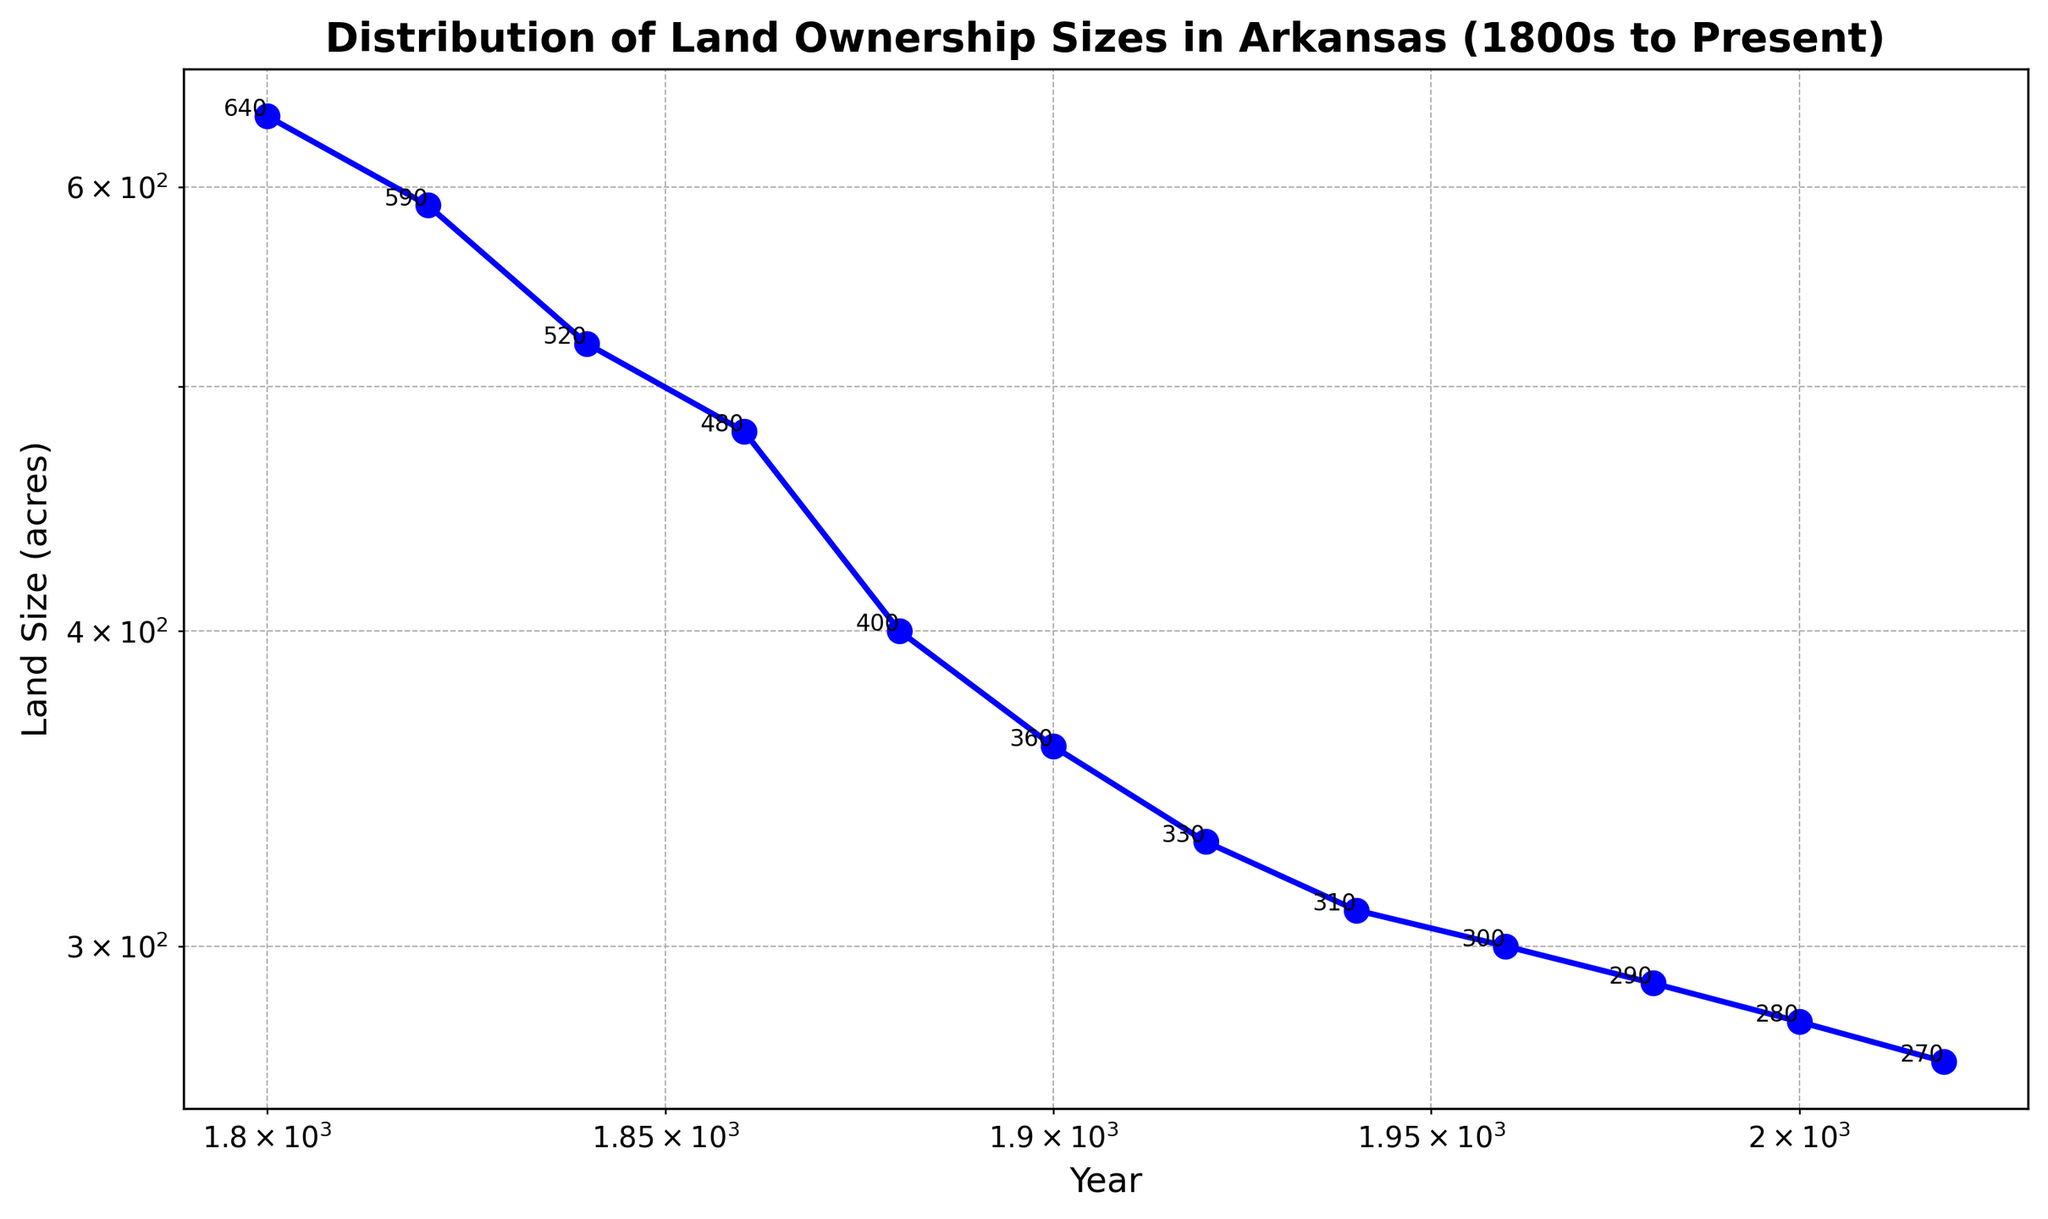Which decade has the most significant decrease in land ownership size? To determine the most significant decrease between decades, we look at the differences between the land sizes in consecutive data points. The calculation would be as follows: 640-590 (50), 590-520 (70), 520-480 (40), 480-400 (80), 400-360 (40), 360-330 (30), 330-310 (20), 310-300 (10), 300-290 (10), 290-280 (10), 280-270 (10). The largest decrease occurs between 1860 and 1880 with 80 acres.
Answer: 1860-1880 What is the average land ownership size over the entire timeline? To find the average, sum all the land ownership sizes and then divide by the number of data points. The sum is 640 + 590 + 520 + 480 + 400 + 360 + 330 + 310 + 300 + 290 + 280 + 270 = 4770 acres. Dividing by 12 data points gives 4770/12.
Answer: 397.5 acres Which period between consecutive years had the least change in land ownership size? Look for the smallest difference in land sizes between consecutive years. The differences calculated are: 640-590 (50), 590-520 (70), 520-480 (40), 480-400 (80), 400-360 (40), 360-330 (30), 330-310 (20), 310-300 (10), 300-290 (10), 290-280 (10), 280-270 (10). The periods 310-300, 300-290, 290-280, and 280-270 all had a decrease of 10 acres, representing the least change.
Answer: 2010-2020 In what year was the land size closest to 500 acres? By examining the land sizes, we notice that in 1840 the size was 520 acres and in 1860 it was 480 acres. The closest is 480 acres in 1860.
Answer: 1860 Which decade shows a decrease in land size by more than 50 acres? Calculate the decrease for each decade. From the differences we earlier calculated: 640-590 (50), 590-520 (70), 520-480 (40), 480-400 (80), 400-360 (40), 360-330 (30), 330-310 (20), 310-300 (10), 300-290 (10), 290-280 (10), 280-270 (10). The periods 1820-1840 (70 acres), 1860-1880 (80 acres) show a decrease in land size by more than 50 acres.
Answer: 1820-1840, 1860-1880 What trend is observed in the land ownership sizes from 1800 to 2020? The general trend observed through the plot is a consistent decrease in land ownership sizes from 640 acres in 1800 to 270 acres in 2020, indicating a steady decline over the years.
Answer: Steady decline How many times does the land size decrease by exactly 10 acres between consecutive data points? Look at the differences between each consecutive year’s land sizes and count instances of a 10-acre decrease: 310-300 (10), 300-290 (10), 290-280 (10), 280-270 (10). This occurs 4 times.
Answer: 4 In which century did the most rapid decrease in land ownership size occur? Look at the differences in each century. The largest single change occurs during the 19th century (1820-1840 with a 70-acre decrease and 1860-1880 with an 80-acre decrease). Summing notable decreases covers the earlier centuries mostly.
Answer: 19th century 